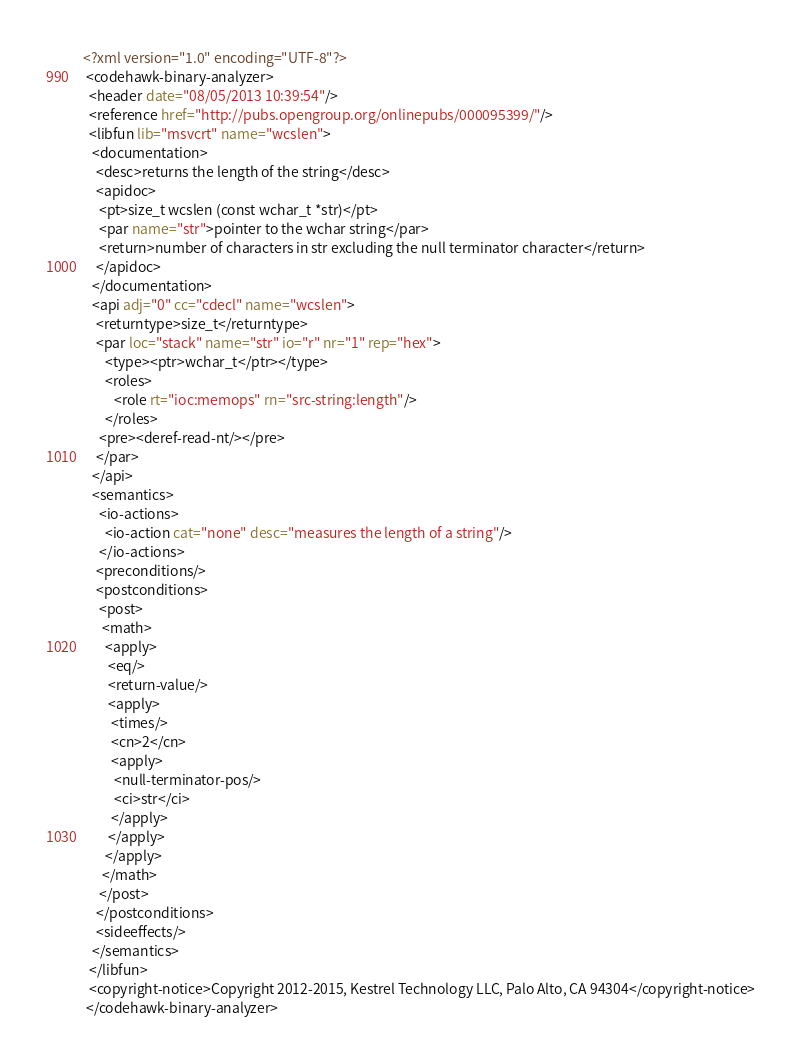<code> <loc_0><loc_0><loc_500><loc_500><_XML_><?xml version="1.0" encoding="UTF-8"?>
 <codehawk-binary-analyzer>
  <header date="08/05/2013 10:39:54"/>
  <reference href="http://pubs.opengroup.org/onlinepubs/000095399/"/>
  <libfun lib="msvcrt" name="wcslen">
   <documentation>
    <desc>returns the length of the string</desc>
    <apidoc>
     <pt>size_t wcslen (const wchar_t *str)</pt>
     <par name="str">pointer to the wchar string</par>
     <return>number of characters in str excluding the null terminator character</return>
    </apidoc>
   </documentation>
   <api adj="0" cc="cdecl" name="wcslen">
    <returntype>size_t</returntype>
    <par loc="stack" name="str" io="r" nr="1" rep="hex">
       <type><ptr>wchar_t</ptr></type>
       <roles>
          <role rt="ioc:memops" rn="src-string:length"/>
       </roles>
     <pre><deref-read-nt/></pre>
    </par>
   </api>
   <semantics>
     <io-actions>
       <io-action cat="none" desc="measures the length of a string"/>
     </io-actions>
    <preconditions/>
    <postconditions>
     <post>
      <math>
       <apply>
        <eq/>
        <return-value/>
        <apply>
         <times/>
         <cn>2</cn>
         <apply>
          <null-terminator-pos/>
          <ci>str</ci>
         </apply>
        </apply>
       </apply>
      </math>
     </post>
    </postconditions>
    <sideeffects/>
   </semantics>
  </libfun>
  <copyright-notice>Copyright 2012-2015, Kestrel Technology LLC, Palo Alto, CA 94304</copyright-notice>
 </codehawk-binary-analyzer>
</code> 